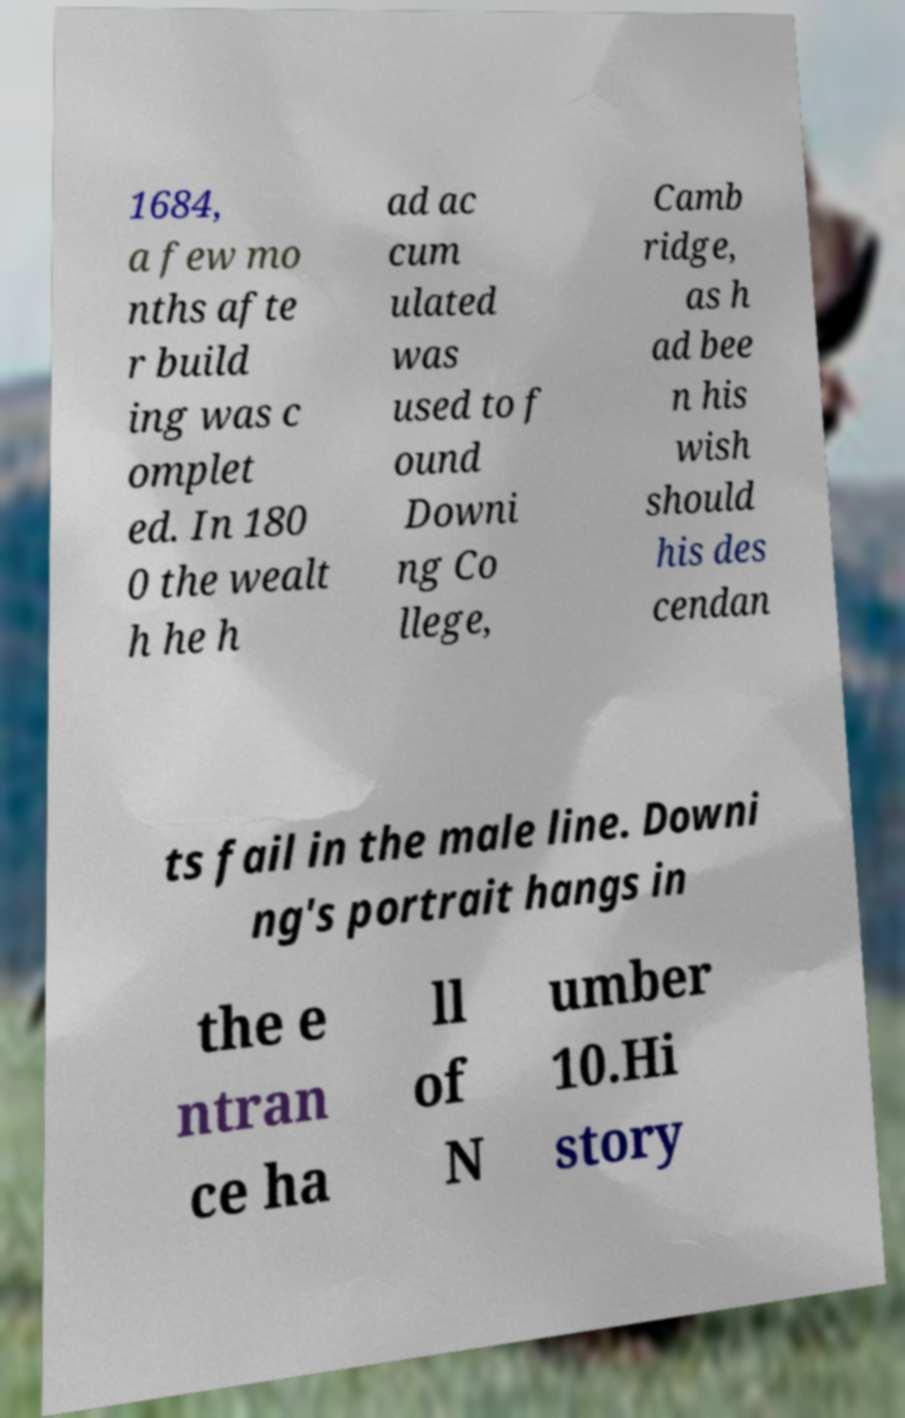Please read and relay the text visible in this image. What does it say? 1684, a few mo nths afte r build ing was c omplet ed. In 180 0 the wealt h he h ad ac cum ulated was used to f ound Downi ng Co llege, Camb ridge, as h ad bee n his wish should his des cendan ts fail in the male line. Downi ng's portrait hangs in the e ntran ce ha ll of N umber 10.Hi story 